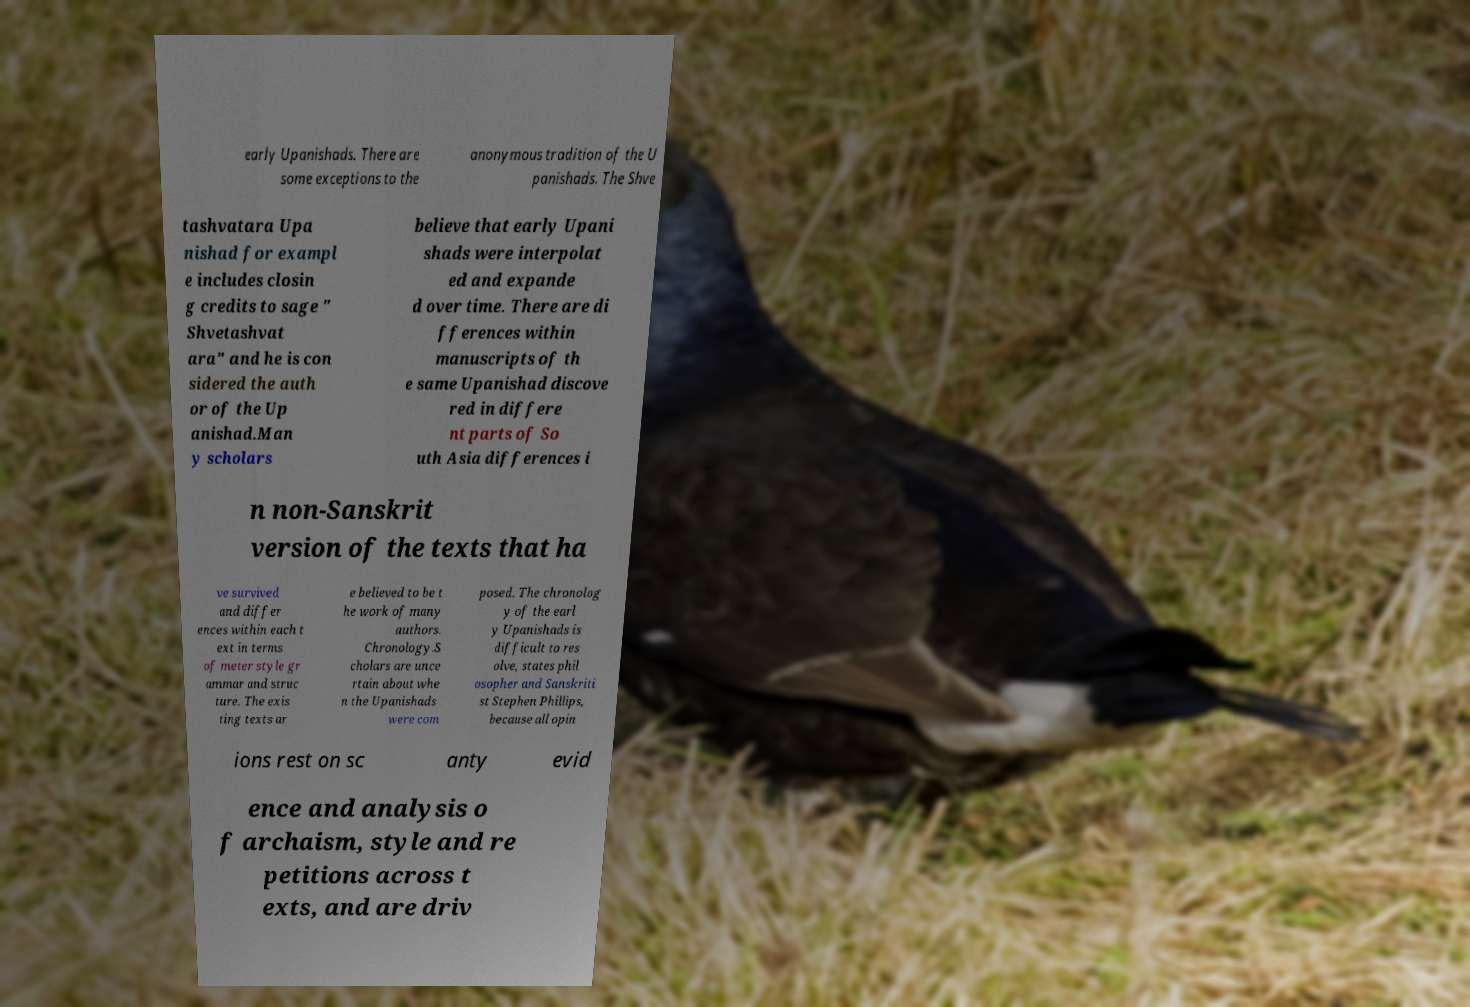What messages or text are displayed in this image? I need them in a readable, typed format. early Upanishads. There are some exceptions to the anonymous tradition of the U panishads. The Shve tashvatara Upa nishad for exampl e includes closin g credits to sage " Shvetashvat ara" and he is con sidered the auth or of the Up anishad.Man y scholars believe that early Upani shads were interpolat ed and expande d over time. There are di fferences within manuscripts of th e same Upanishad discove red in differe nt parts of So uth Asia differences i n non-Sanskrit version of the texts that ha ve survived and differ ences within each t ext in terms of meter style gr ammar and struc ture. The exis ting texts ar e believed to be t he work of many authors. Chronology.S cholars are unce rtain about whe n the Upanishads were com posed. The chronolog y of the earl y Upanishads is difficult to res olve, states phil osopher and Sanskriti st Stephen Phillips, because all opin ions rest on sc anty evid ence and analysis o f archaism, style and re petitions across t exts, and are driv 